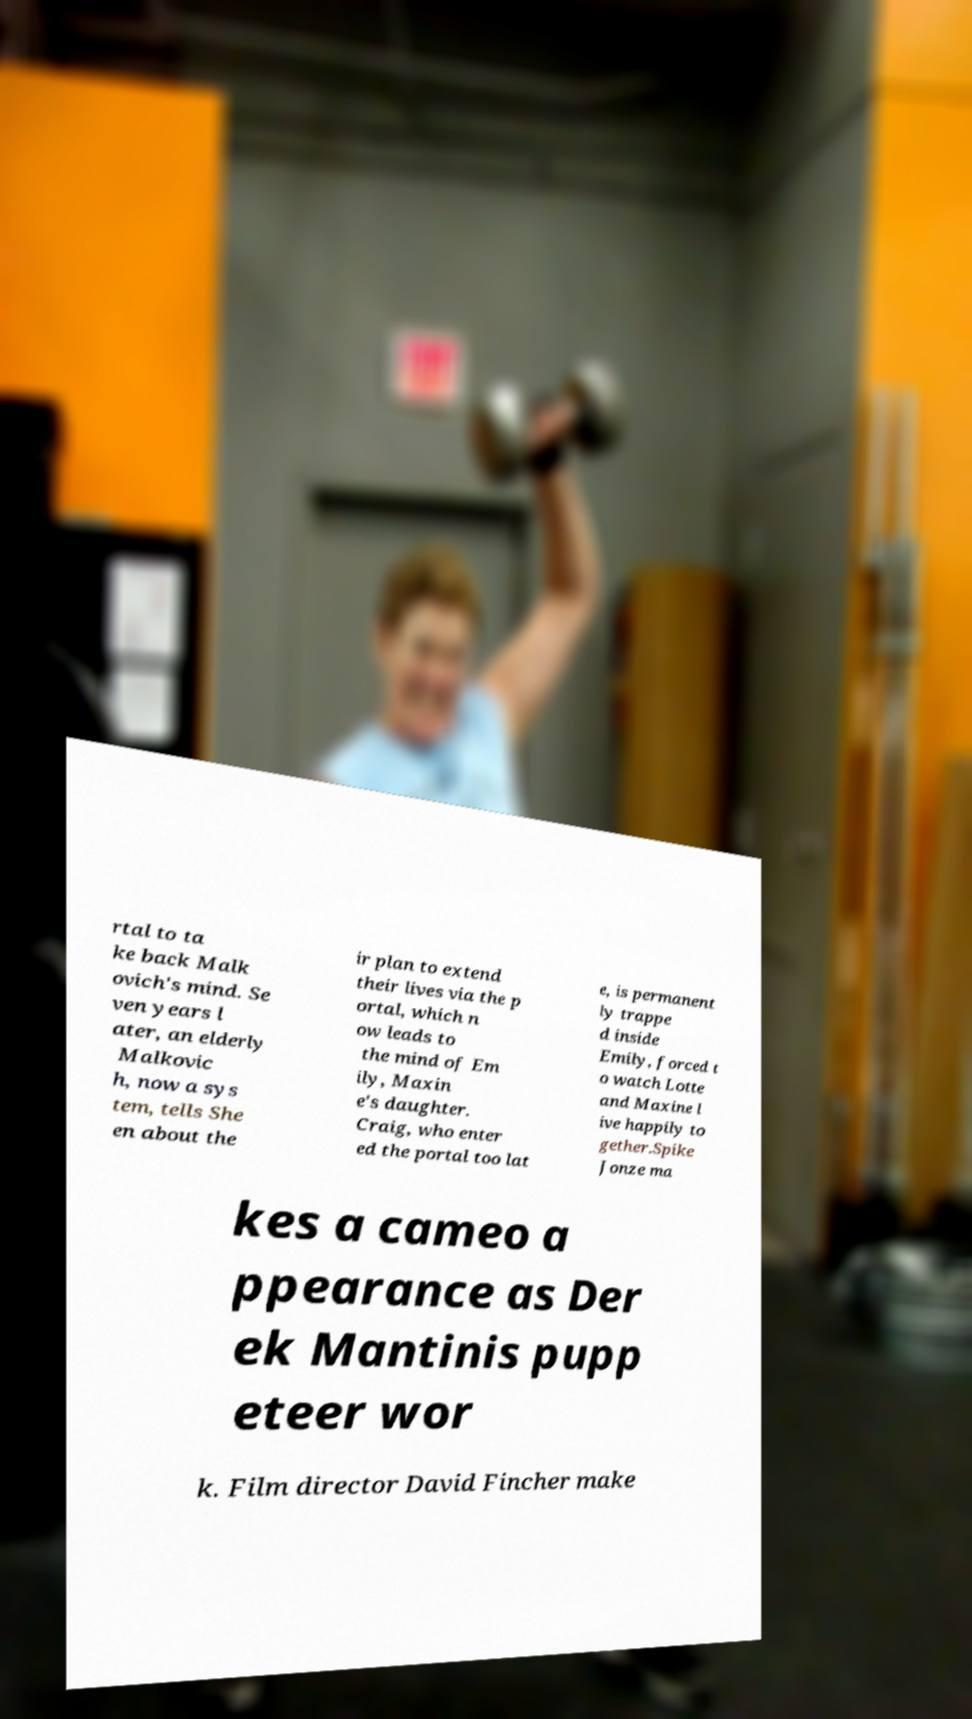Could you extract and type out the text from this image? rtal to ta ke back Malk ovich's mind. Se ven years l ater, an elderly Malkovic h, now a sys tem, tells She en about the ir plan to extend their lives via the p ortal, which n ow leads to the mind of Em ily, Maxin e's daughter. Craig, who enter ed the portal too lat e, is permanent ly trappe d inside Emily, forced t o watch Lotte and Maxine l ive happily to gether.Spike Jonze ma kes a cameo a ppearance as Der ek Mantinis pupp eteer wor k. Film director David Fincher make 